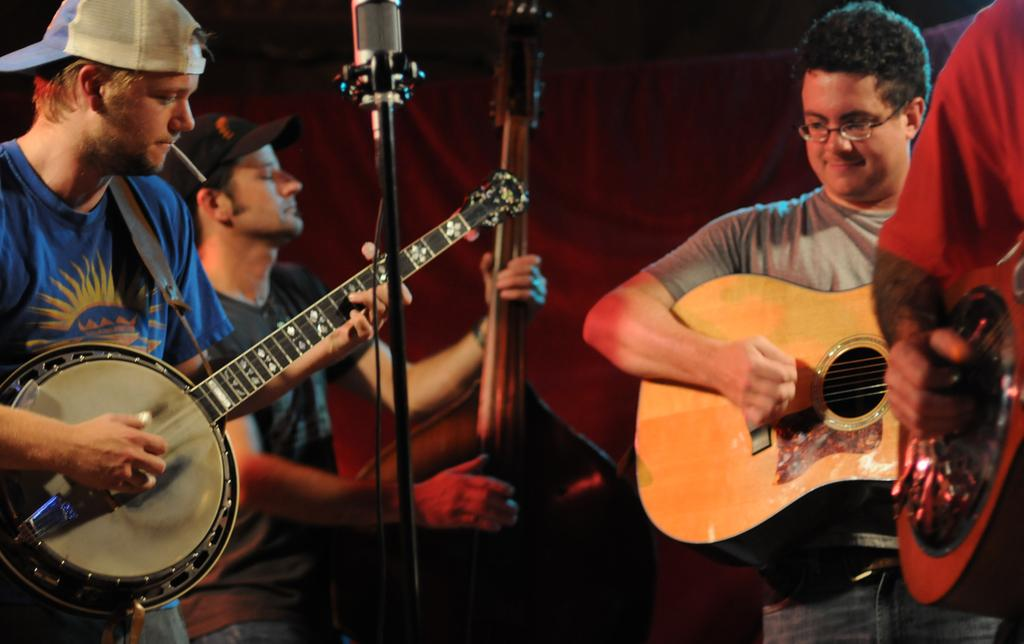How many people are in the image? There is a group of people in the image. What are the people in the image doing? The people are playing guitar. Can you show me the receipt for the guitars in the image? There is no receipt present in the image; it only shows people playing guitar. 